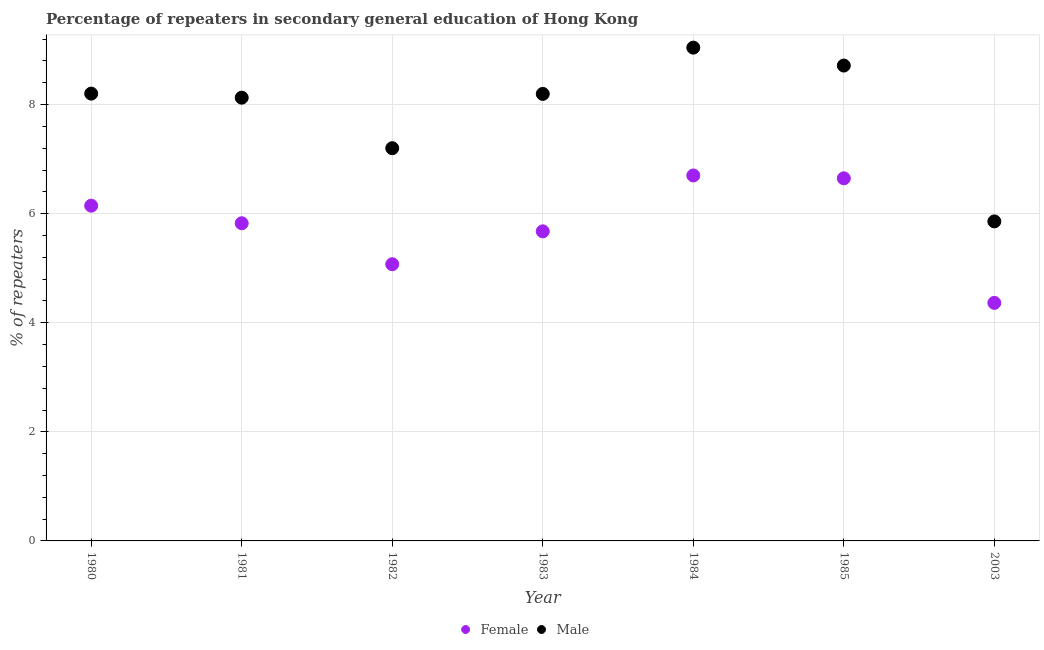Is the number of dotlines equal to the number of legend labels?
Offer a terse response. Yes. What is the percentage of male repeaters in 2003?
Offer a very short reply. 5.86. Across all years, what is the maximum percentage of female repeaters?
Provide a succinct answer. 6.7. Across all years, what is the minimum percentage of male repeaters?
Offer a terse response. 5.86. What is the total percentage of male repeaters in the graph?
Offer a very short reply. 55.34. What is the difference between the percentage of male repeaters in 1981 and that in 1985?
Ensure brevity in your answer.  -0.59. What is the difference between the percentage of female repeaters in 1983 and the percentage of male repeaters in 1980?
Ensure brevity in your answer.  -2.53. What is the average percentage of male repeaters per year?
Your answer should be very brief. 7.91. In the year 1982, what is the difference between the percentage of male repeaters and percentage of female repeaters?
Your answer should be very brief. 2.13. In how many years, is the percentage of female repeaters greater than 4.8 %?
Your response must be concise. 6. What is the ratio of the percentage of male repeaters in 1981 to that in 1983?
Keep it short and to the point. 0.99. Is the percentage of male repeaters in 1980 less than that in 1982?
Make the answer very short. No. Is the difference between the percentage of female repeaters in 1980 and 1982 greater than the difference between the percentage of male repeaters in 1980 and 1982?
Make the answer very short. Yes. What is the difference between the highest and the second highest percentage of male repeaters?
Keep it short and to the point. 0.33. What is the difference between the highest and the lowest percentage of female repeaters?
Your response must be concise. 2.34. In how many years, is the percentage of male repeaters greater than the average percentage of male repeaters taken over all years?
Your answer should be very brief. 5. Does the percentage of female repeaters monotonically increase over the years?
Offer a terse response. No. How many dotlines are there?
Your answer should be compact. 2. How many years are there in the graph?
Your answer should be very brief. 7. What is the difference between two consecutive major ticks on the Y-axis?
Provide a short and direct response. 2. Are the values on the major ticks of Y-axis written in scientific E-notation?
Provide a short and direct response. No. Does the graph contain any zero values?
Provide a succinct answer. No. How are the legend labels stacked?
Offer a very short reply. Horizontal. What is the title of the graph?
Ensure brevity in your answer.  Percentage of repeaters in secondary general education of Hong Kong. Does "Broad money growth" appear as one of the legend labels in the graph?
Make the answer very short. No. What is the label or title of the Y-axis?
Your answer should be compact. % of repeaters. What is the % of repeaters of Female in 1980?
Your response must be concise. 6.15. What is the % of repeaters in Male in 1980?
Provide a short and direct response. 8.2. What is the % of repeaters of Female in 1981?
Offer a terse response. 5.82. What is the % of repeaters of Male in 1981?
Your answer should be very brief. 8.13. What is the % of repeaters in Female in 1982?
Your answer should be compact. 5.07. What is the % of repeaters of Male in 1982?
Offer a terse response. 7.2. What is the % of repeaters in Female in 1983?
Your response must be concise. 5.68. What is the % of repeaters in Male in 1983?
Your response must be concise. 8.2. What is the % of repeaters in Female in 1984?
Offer a terse response. 6.7. What is the % of repeaters of Male in 1984?
Make the answer very short. 9.04. What is the % of repeaters in Female in 1985?
Make the answer very short. 6.65. What is the % of repeaters in Male in 1985?
Your response must be concise. 8.72. What is the % of repeaters of Female in 2003?
Keep it short and to the point. 4.36. What is the % of repeaters in Male in 2003?
Ensure brevity in your answer.  5.86. Across all years, what is the maximum % of repeaters of Female?
Provide a succinct answer. 6.7. Across all years, what is the maximum % of repeaters in Male?
Offer a terse response. 9.04. Across all years, what is the minimum % of repeaters of Female?
Offer a very short reply. 4.36. Across all years, what is the minimum % of repeaters in Male?
Offer a very short reply. 5.86. What is the total % of repeaters in Female in the graph?
Give a very brief answer. 40.43. What is the total % of repeaters of Male in the graph?
Offer a very short reply. 55.34. What is the difference between the % of repeaters of Female in 1980 and that in 1981?
Offer a very short reply. 0.32. What is the difference between the % of repeaters of Male in 1980 and that in 1981?
Provide a succinct answer. 0.07. What is the difference between the % of repeaters of Female in 1980 and that in 1982?
Ensure brevity in your answer.  1.07. What is the difference between the % of repeaters of Female in 1980 and that in 1983?
Provide a succinct answer. 0.47. What is the difference between the % of repeaters in Male in 1980 and that in 1983?
Make the answer very short. 0.01. What is the difference between the % of repeaters in Female in 1980 and that in 1984?
Keep it short and to the point. -0.55. What is the difference between the % of repeaters of Male in 1980 and that in 1984?
Your answer should be very brief. -0.84. What is the difference between the % of repeaters in Female in 1980 and that in 1985?
Offer a very short reply. -0.5. What is the difference between the % of repeaters of Male in 1980 and that in 1985?
Keep it short and to the point. -0.51. What is the difference between the % of repeaters in Female in 1980 and that in 2003?
Your answer should be very brief. 1.78. What is the difference between the % of repeaters in Male in 1980 and that in 2003?
Keep it short and to the point. 2.34. What is the difference between the % of repeaters of Female in 1981 and that in 1982?
Offer a very short reply. 0.75. What is the difference between the % of repeaters of Male in 1981 and that in 1982?
Provide a succinct answer. 0.93. What is the difference between the % of repeaters of Female in 1981 and that in 1983?
Make the answer very short. 0.15. What is the difference between the % of repeaters of Male in 1981 and that in 1983?
Your response must be concise. -0.07. What is the difference between the % of repeaters of Female in 1981 and that in 1984?
Ensure brevity in your answer.  -0.88. What is the difference between the % of repeaters in Male in 1981 and that in 1984?
Keep it short and to the point. -0.92. What is the difference between the % of repeaters in Female in 1981 and that in 1985?
Give a very brief answer. -0.82. What is the difference between the % of repeaters in Male in 1981 and that in 1985?
Your response must be concise. -0.59. What is the difference between the % of repeaters in Female in 1981 and that in 2003?
Provide a succinct answer. 1.46. What is the difference between the % of repeaters in Male in 1981 and that in 2003?
Ensure brevity in your answer.  2.27. What is the difference between the % of repeaters of Female in 1982 and that in 1983?
Keep it short and to the point. -0.6. What is the difference between the % of repeaters in Male in 1982 and that in 1983?
Give a very brief answer. -1. What is the difference between the % of repeaters in Female in 1982 and that in 1984?
Your answer should be very brief. -1.63. What is the difference between the % of repeaters in Male in 1982 and that in 1984?
Make the answer very short. -1.84. What is the difference between the % of repeaters of Female in 1982 and that in 1985?
Offer a very short reply. -1.58. What is the difference between the % of repeaters in Male in 1982 and that in 1985?
Give a very brief answer. -1.52. What is the difference between the % of repeaters of Female in 1982 and that in 2003?
Ensure brevity in your answer.  0.71. What is the difference between the % of repeaters of Male in 1982 and that in 2003?
Provide a succinct answer. 1.34. What is the difference between the % of repeaters of Female in 1983 and that in 1984?
Keep it short and to the point. -1.02. What is the difference between the % of repeaters of Male in 1983 and that in 1984?
Make the answer very short. -0.85. What is the difference between the % of repeaters of Female in 1983 and that in 1985?
Your answer should be very brief. -0.97. What is the difference between the % of repeaters in Male in 1983 and that in 1985?
Give a very brief answer. -0.52. What is the difference between the % of repeaters of Female in 1983 and that in 2003?
Your answer should be very brief. 1.31. What is the difference between the % of repeaters of Male in 1983 and that in 2003?
Make the answer very short. 2.34. What is the difference between the % of repeaters in Female in 1984 and that in 1985?
Your answer should be very brief. 0.05. What is the difference between the % of repeaters of Male in 1984 and that in 1985?
Offer a terse response. 0.33. What is the difference between the % of repeaters of Female in 1984 and that in 2003?
Offer a very short reply. 2.34. What is the difference between the % of repeaters in Male in 1984 and that in 2003?
Make the answer very short. 3.19. What is the difference between the % of repeaters in Female in 1985 and that in 2003?
Keep it short and to the point. 2.28. What is the difference between the % of repeaters of Male in 1985 and that in 2003?
Your answer should be very brief. 2.86. What is the difference between the % of repeaters in Female in 1980 and the % of repeaters in Male in 1981?
Keep it short and to the point. -1.98. What is the difference between the % of repeaters in Female in 1980 and the % of repeaters in Male in 1982?
Your response must be concise. -1.05. What is the difference between the % of repeaters in Female in 1980 and the % of repeaters in Male in 1983?
Provide a short and direct response. -2.05. What is the difference between the % of repeaters in Female in 1980 and the % of repeaters in Male in 1984?
Keep it short and to the point. -2.9. What is the difference between the % of repeaters in Female in 1980 and the % of repeaters in Male in 1985?
Ensure brevity in your answer.  -2.57. What is the difference between the % of repeaters of Female in 1980 and the % of repeaters of Male in 2003?
Your answer should be very brief. 0.29. What is the difference between the % of repeaters of Female in 1981 and the % of repeaters of Male in 1982?
Ensure brevity in your answer.  -1.38. What is the difference between the % of repeaters in Female in 1981 and the % of repeaters in Male in 1983?
Give a very brief answer. -2.37. What is the difference between the % of repeaters in Female in 1981 and the % of repeaters in Male in 1984?
Provide a succinct answer. -3.22. What is the difference between the % of repeaters of Female in 1981 and the % of repeaters of Male in 1985?
Offer a terse response. -2.89. What is the difference between the % of repeaters of Female in 1981 and the % of repeaters of Male in 2003?
Offer a terse response. -0.03. What is the difference between the % of repeaters in Female in 1982 and the % of repeaters in Male in 1983?
Offer a terse response. -3.12. What is the difference between the % of repeaters of Female in 1982 and the % of repeaters of Male in 1984?
Offer a very short reply. -3.97. What is the difference between the % of repeaters in Female in 1982 and the % of repeaters in Male in 1985?
Offer a terse response. -3.64. What is the difference between the % of repeaters of Female in 1982 and the % of repeaters of Male in 2003?
Your response must be concise. -0.79. What is the difference between the % of repeaters of Female in 1983 and the % of repeaters of Male in 1984?
Your response must be concise. -3.37. What is the difference between the % of repeaters in Female in 1983 and the % of repeaters in Male in 1985?
Offer a terse response. -3.04. What is the difference between the % of repeaters in Female in 1983 and the % of repeaters in Male in 2003?
Your response must be concise. -0.18. What is the difference between the % of repeaters in Female in 1984 and the % of repeaters in Male in 1985?
Offer a terse response. -2.02. What is the difference between the % of repeaters in Female in 1984 and the % of repeaters in Male in 2003?
Your response must be concise. 0.84. What is the difference between the % of repeaters in Female in 1985 and the % of repeaters in Male in 2003?
Your answer should be very brief. 0.79. What is the average % of repeaters of Female per year?
Offer a terse response. 5.78. What is the average % of repeaters of Male per year?
Make the answer very short. 7.91. In the year 1980, what is the difference between the % of repeaters in Female and % of repeaters in Male?
Ensure brevity in your answer.  -2.05. In the year 1981, what is the difference between the % of repeaters in Female and % of repeaters in Male?
Ensure brevity in your answer.  -2.3. In the year 1982, what is the difference between the % of repeaters in Female and % of repeaters in Male?
Make the answer very short. -2.13. In the year 1983, what is the difference between the % of repeaters of Female and % of repeaters of Male?
Keep it short and to the point. -2.52. In the year 1984, what is the difference between the % of repeaters in Female and % of repeaters in Male?
Your answer should be compact. -2.34. In the year 1985, what is the difference between the % of repeaters of Female and % of repeaters of Male?
Make the answer very short. -2.07. In the year 2003, what is the difference between the % of repeaters of Female and % of repeaters of Male?
Give a very brief answer. -1.49. What is the ratio of the % of repeaters in Female in 1980 to that in 1981?
Offer a terse response. 1.06. What is the ratio of the % of repeaters of Male in 1980 to that in 1981?
Make the answer very short. 1.01. What is the ratio of the % of repeaters in Female in 1980 to that in 1982?
Provide a succinct answer. 1.21. What is the ratio of the % of repeaters of Male in 1980 to that in 1982?
Provide a short and direct response. 1.14. What is the ratio of the % of repeaters in Female in 1980 to that in 1983?
Offer a terse response. 1.08. What is the ratio of the % of repeaters in Male in 1980 to that in 1983?
Offer a terse response. 1. What is the ratio of the % of repeaters of Female in 1980 to that in 1984?
Keep it short and to the point. 0.92. What is the ratio of the % of repeaters in Male in 1980 to that in 1984?
Offer a terse response. 0.91. What is the ratio of the % of repeaters of Female in 1980 to that in 1985?
Your response must be concise. 0.92. What is the ratio of the % of repeaters of Male in 1980 to that in 1985?
Keep it short and to the point. 0.94. What is the ratio of the % of repeaters in Female in 1980 to that in 2003?
Give a very brief answer. 1.41. What is the ratio of the % of repeaters of Male in 1980 to that in 2003?
Keep it short and to the point. 1.4. What is the ratio of the % of repeaters in Female in 1981 to that in 1982?
Make the answer very short. 1.15. What is the ratio of the % of repeaters of Male in 1981 to that in 1982?
Your answer should be very brief. 1.13. What is the ratio of the % of repeaters in Female in 1981 to that in 1983?
Your response must be concise. 1.03. What is the ratio of the % of repeaters of Male in 1981 to that in 1983?
Keep it short and to the point. 0.99. What is the ratio of the % of repeaters in Female in 1981 to that in 1984?
Provide a short and direct response. 0.87. What is the ratio of the % of repeaters in Male in 1981 to that in 1984?
Ensure brevity in your answer.  0.9. What is the ratio of the % of repeaters of Female in 1981 to that in 1985?
Offer a very short reply. 0.88. What is the ratio of the % of repeaters of Male in 1981 to that in 1985?
Make the answer very short. 0.93. What is the ratio of the % of repeaters in Female in 1981 to that in 2003?
Ensure brevity in your answer.  1.33. What is the ratio of the % of repeaters in Male in 1981 to that in 2003?
Give a very brief answer. 1.39. What is the ratio of the % of repeaters in Female in 1982 to that in 1983?
Provide a succinct answer. 0.89. What is the ratio of the % of repeaters of Male in 1982 to that in 1983?
Give a very brief answer. 0.88. What is the ratio of the % of repeaters in Female in 1982 to that in 1984?
Ensure brevity in your answer.  0.76. What is the ratio of the % of repeaters of Male in 1982 to that in 1984?
Your response must be concise. 0.8. What is the ratio of the % of repeaters in Female in 1982 to that in 1985?
Your answer should be compact. 0.76. What is the ratio of the % of repeaters of Male in 1982 to that in 1985?
Keep it short and to the point. 0.83. What is the ratio of the % of repeaters in Female in 1982 to that in 2003?
Your response must be concise. 1.16. What is the ratio of the % of repeaters of Male in 1982 to that in 2003?
Make the answer very short. 1.23. What is the ratio of the % of repeaters in Female in 1983 to that in 1984?
Provide a succinct answer. 0.85. What is the ratio of the % of repeaters in Male in 1983 to that in 1984?
Make the answer very short. 0.91. What is the ratio of the % of repeaters of Female in 1983 to that in 1985?
Offer a very short reply. 0.85. What is the ratio of the % of repeaters of Male in 1983 to that in 1985?
Ensure brevity in your answer.  0.94. What is the ratio of the % of repeaters in Female in 1983 to that in 2003?
Make the answer very short. 1.3. What is the ratio of the % of repeaters of Male in 1983 to that in 2003?
Keep it short and to the point. 1.4. What is the ratio of the % of repeaters in Female in 1984 to that in 1985?
Offer a terse response. 1.01. What is the ratio of the % of repeaters of Male in 1984 to that in 1985?
Your response must be concise. 1.04. What is the ratio of the % of repeaters of Female in 1984 to that in 2003?
Your answer should be compact. 1.54. What is the ratio of the % of repeaters of Male in 1984 to that in 2003?
Your answer should be very brief. 1.54. What is the ratio of the % of repeaters in Female in 1985 to that in 2003?
Your answer should be compact. 1.52. What is the ratio of the % of repeaters of Male in 1985 to that in 2003?
Offer a very short reply. 1.49. What is the difference between the highest and the second highest % of repeaters in Female?
Your answer should be compact. 0.05. What is the difference between the highest and the second highest % of repeaters of Male?
Give a very brief answer. 0.33. What is the difference between the highest and the lowest % of repeaters of Female?
Give a very brief answer. 2.34. What is the difference between the highest and the lowest % of repeaters of Male?
Offer a very short reply. 3.19. 